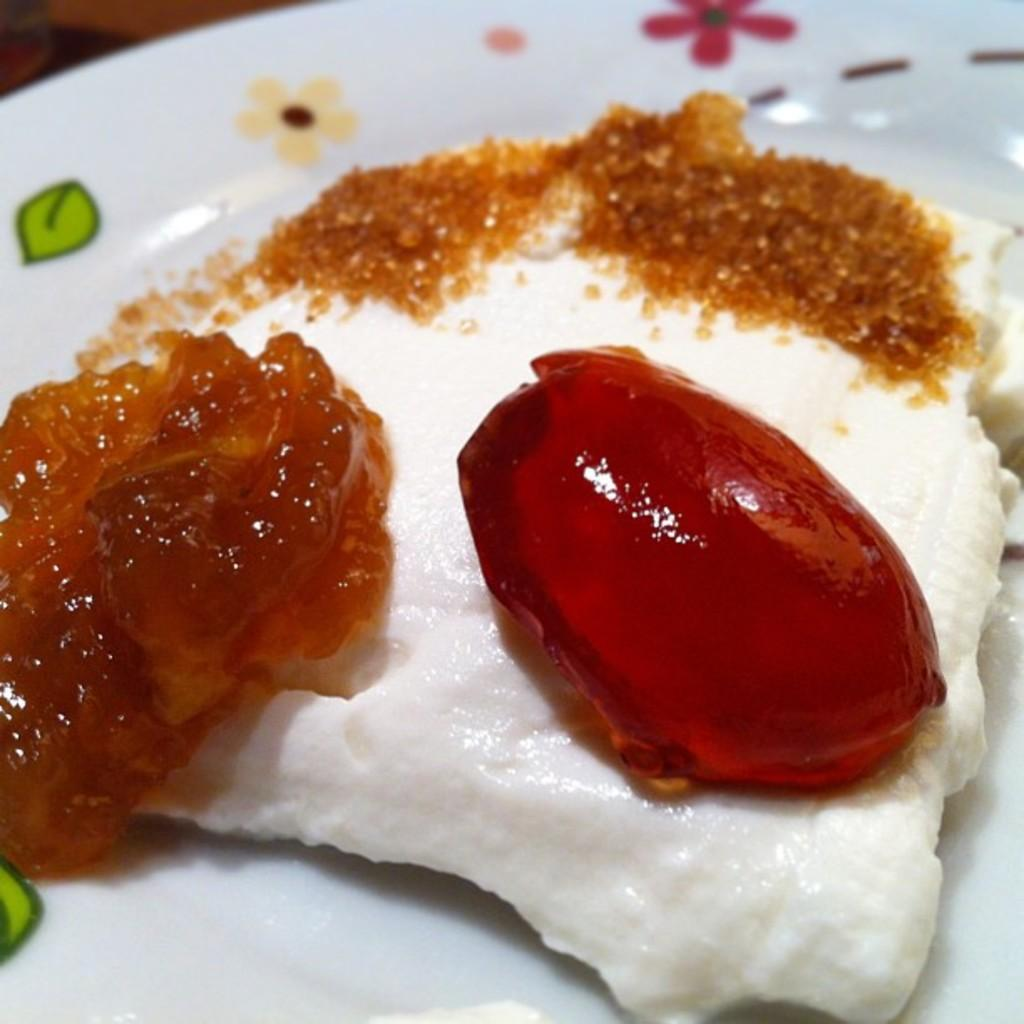What is the color and design of the plate in the image? The plate in the image is white and has a floral design. What is on the plate? The plate contains some food item. How many letters are visible on the plate in the image? There are no letters visible on the plate in the image; it is a floral plate with a food item on it. 